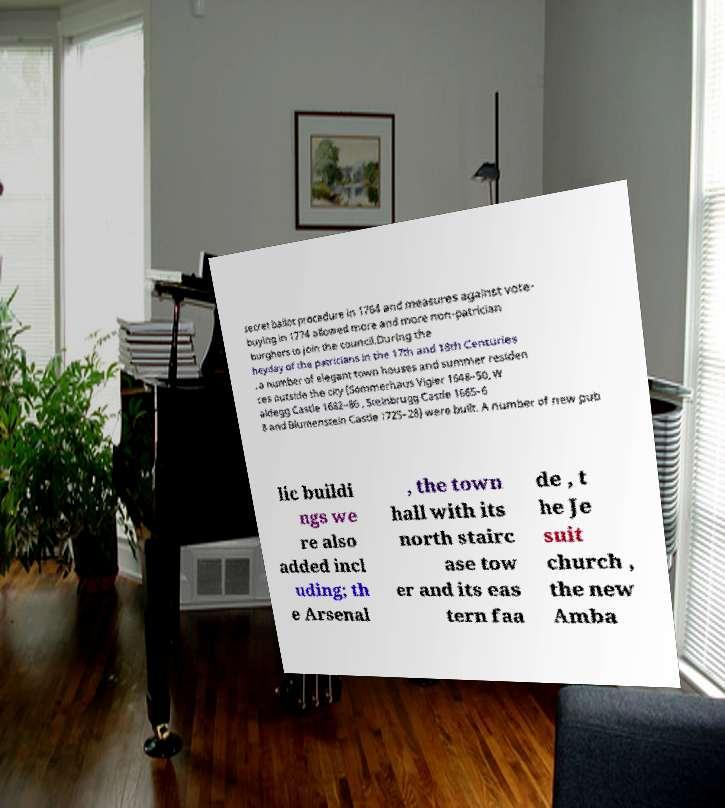What messages or text are displayed in this image? I need them in a readable, typed format. secret ballot procedure in 1764 and measures against vote- buying in 1774 allowed more and more non-patrician burghers to join the council.During the heyday of the patricians in the 17th and 18th Centuries , a number of elegant town houses and summer residen ces outside the city (Sommerhaus Vigier 1648–50, W aldegg Castle 1682–86 , Steinbrugg Castle 1665–6 8 and Blumenstein Castle 1725–28) were built. A number of new pub lic buildi ngs we re also added incl uding; th e Arsenal , the town hall with its north stairc ase tow er and its eas tern faa de , t he Je suit church , the new Amba 